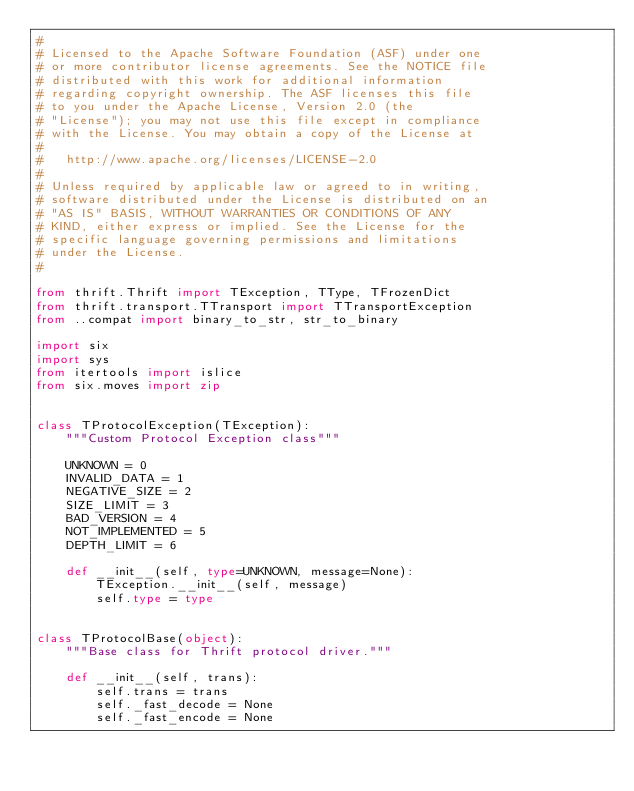Convert code to text. <code><loc_0><loc_0><loc_500><loc_500><_Python_>#
# Licensed to the Apache Software Foundation (ASF) under one
# or more contributor license agreements. See the NOTICE file
# distributed with this work for additional information
# regarding copyright ownership. The ASF licenses this file
# to you under the Apache License, Version 2.0 (the
# "License"); you may not use this file except in compliance
# with the License. You may obtain a copy of the License at
#
#   http://www.apache.org/licenses/LICENSE-2.0
#
# Unless required by applicable law or agreed to in writing,
# software distributed under the License is distributed on an
# "AS IS" BASIS, WITHOUT WARRANTIES OR CONDITIONS OF ANY
# KIND, either express or implied. See the License for the
# specific language governing permissions and limitations
# under the License.
#

from thrift.Thrift import TException, TType, TFrozenDict
from thrift.transport.TTransport import TTransportException
from ..compat import binary_to_str, str_to_binary

import six
import sys
from itertools import islice
from six.moves import zip


class TProtocolException(TException):
    """Custom Protocol Exception class"""

    UNKNOWN = 0
    INVALID_DATA = 1
    NEGATIVE_SIZE = 2
    SIZE_LIMIT = 3
    BAD_VERSION = 4
    NOT_IMPLEMENTED = 5
    DEPTH_LIMIT = 6

    def __init__(self, type=UNKNOWN, message=None):
        TException.__init__(self, message)
        self.type = type


class TProtocolBase(object):
    """Base class for Thrift protocol driver."""

    def __init__(self, trans):
        self.trans = trans
        self._fast_decode = None
        self._fast_encode = None
</code> 